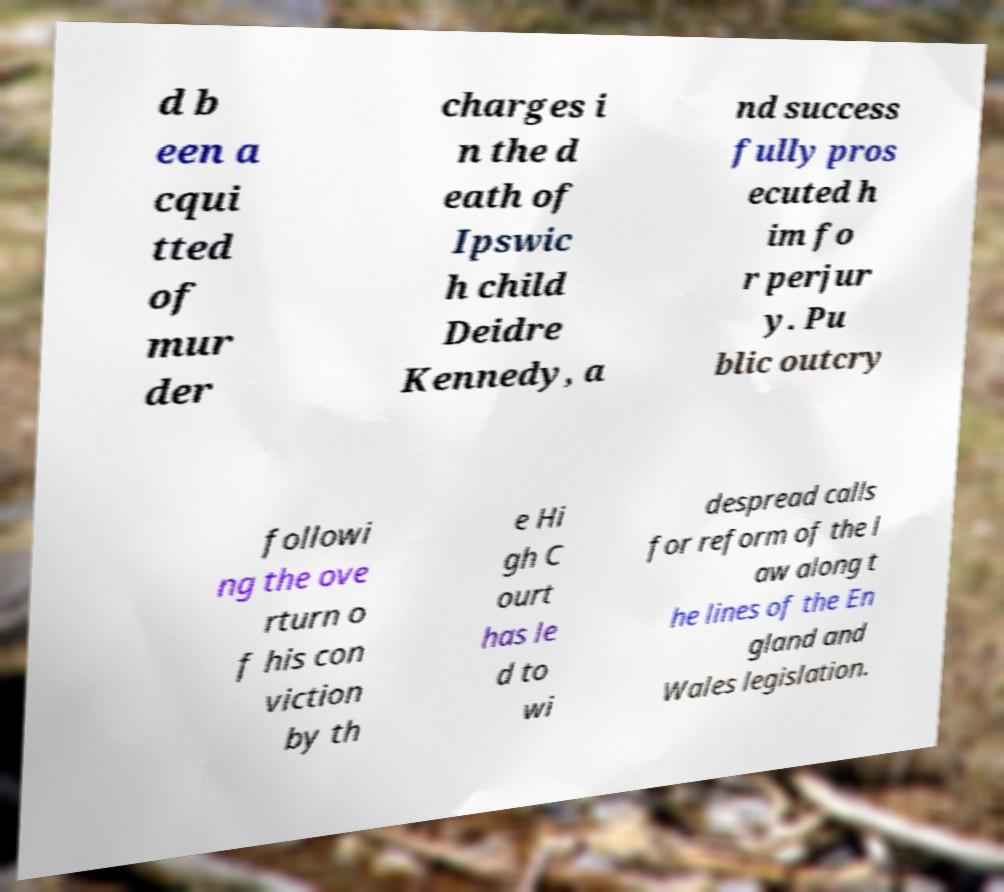I need the written content from this picture converted into text. Can you do that? d b een a cqui tted of mur der charges i n the d eath of Ipswic h child Deidre Kennedy, a nd success fully pros ecuted h im fo r perjur y. Pu blic outcry followi ng the ove rturn o f his con viction by th e Hi gh C ourt has le d to wi despread calls for reform of the l aw along t he lines of the En gland and Wales legislation. 